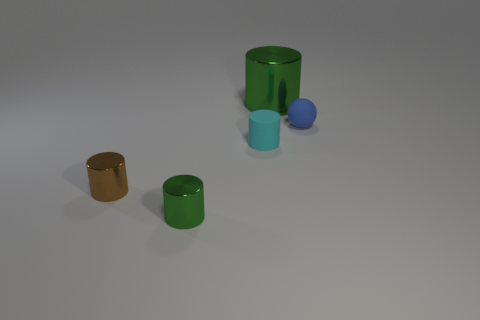Subtract all purple cylinders. Subtract all brown spheres. How many cylinders are left? 4 Add 2 tiny matte spheres. How many objects exist? 7 Subtract all cylinders. How many objects are left? 1 Subtract all small matte blocks. Subtract all big objects. How many objects are left? 4 Add 1 tiny blue rubber spheres. How many tiny blue rubber spheres are left? 2 Add 3 tiny blue rubber things. How many tiny blue rubber things exist? 4 Subtract 0 blue cubes. How many objects are left? 5 